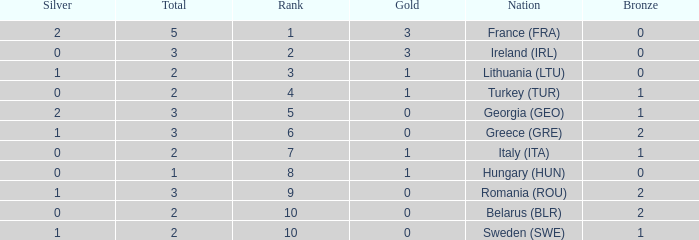What's the total of rank 8 when Silver medals are 0 and gold is more than 1? 0.0. 